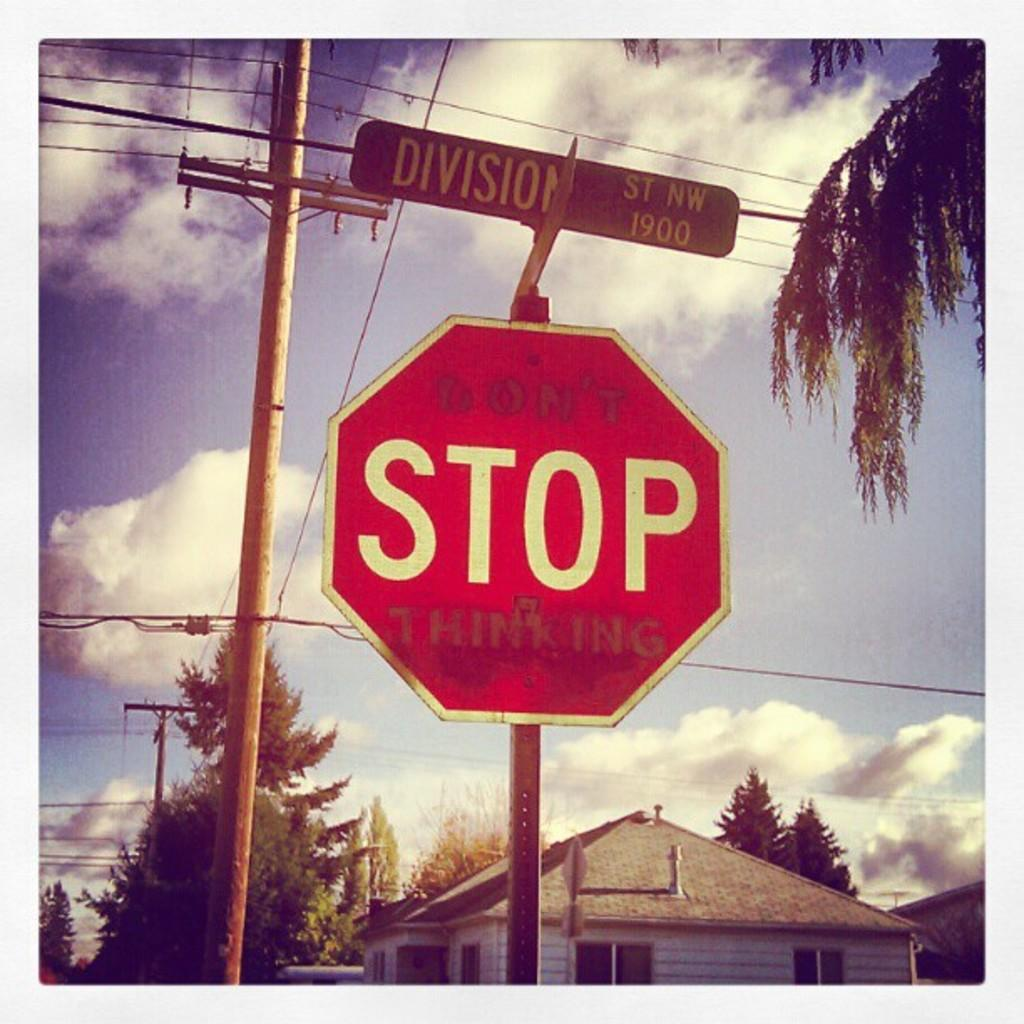Provide a one-sentence caption for the provided image. A stop sign covered in graffitti that says "Don't stop thinking.". 